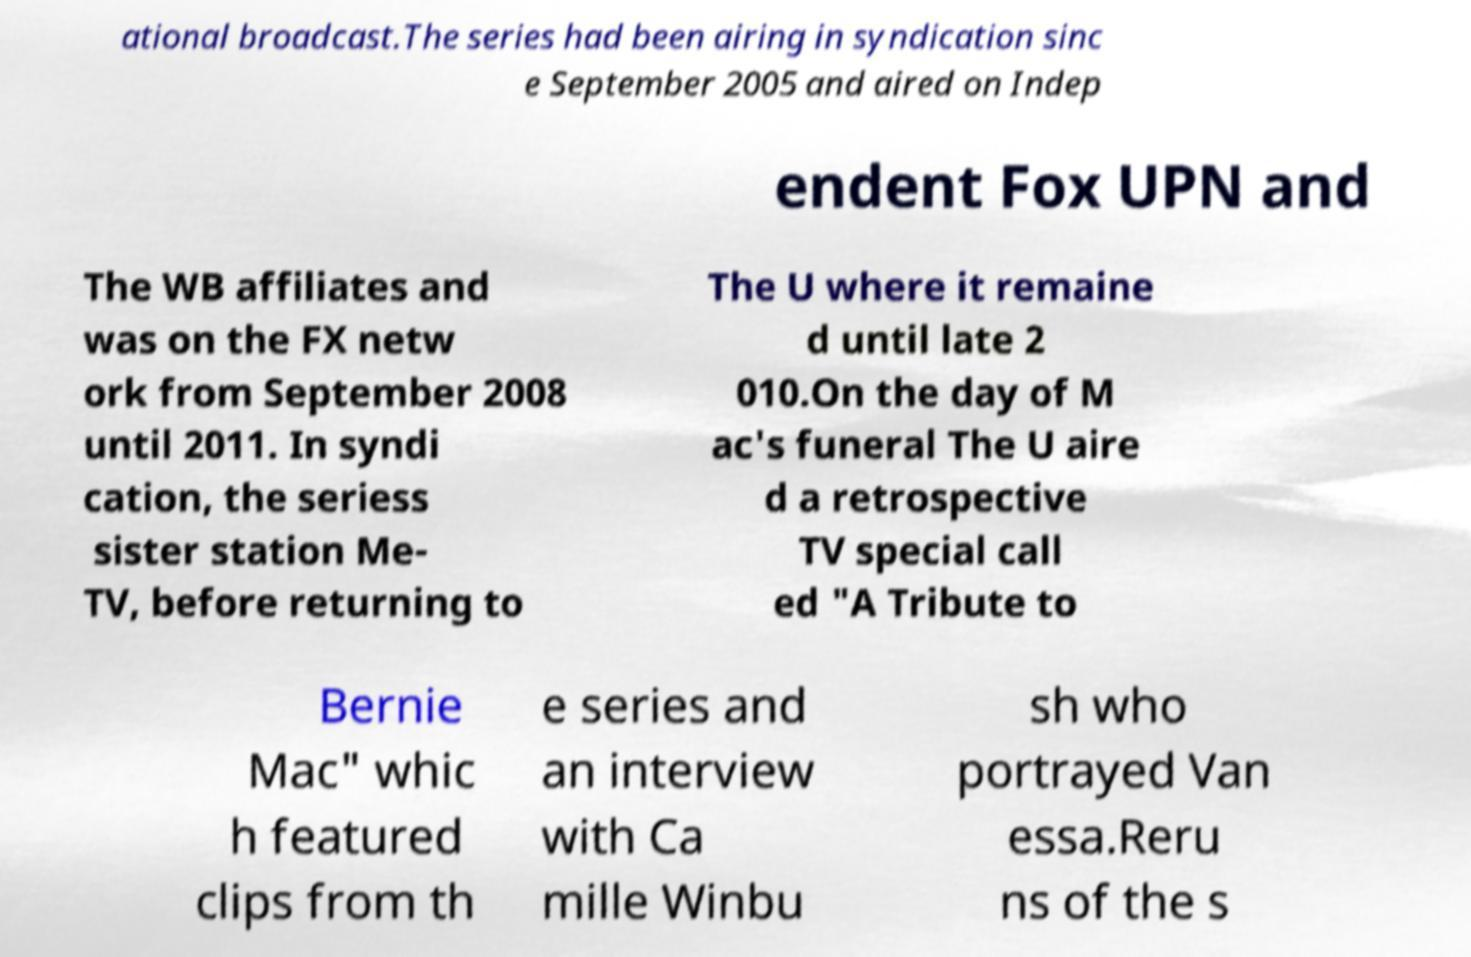Can you read and provide the text displayed in the image?This photo seems to have some interesting text. Can you extract and type it out for me? ational broadcast.The series had been airing in syndication sinc e September 2005 and aired on Indep endent Fox UPN and The WB affiliates and was on the FX netw ork from September 2008 until 2011. In syndi cation, the seriess sister station Me- TV, before returning to The U where it remaine d until late 2 010.On the day of M ac's funeral The U aire d a retrospective TV special call ed "A Tribute to Bernie Mac" whic h featured clips from th e series and an interview with Ca mille Winbu sh who portrayed Van essa.Reru ns of the s 